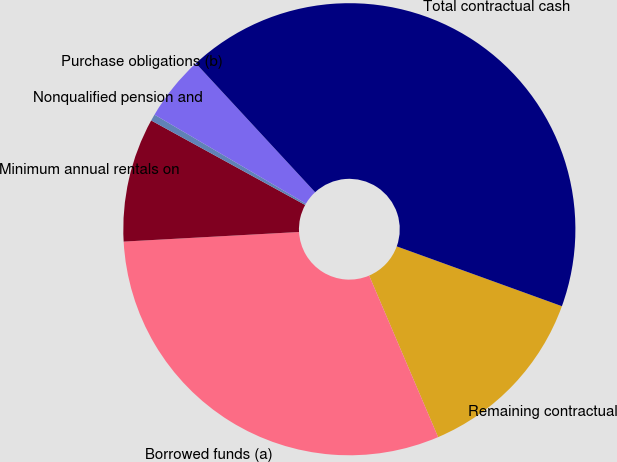<chart> <loc_0><loc_0><loc_500><loc_500><pie_chart><fcel>Remaining contractual<fcel>Borrowed funds (a)<fcel>Minimum annual rentals on<fcel>Nonqualified pension and<fcel>Purchase obligations (b)<fcel>Total contractual cash<nl><fcel>13.05%<fcel>30.55%<fcel>8.86%<fcel>0.47%<fcel>4.66%<fcel>42.41%<nl></chart> 